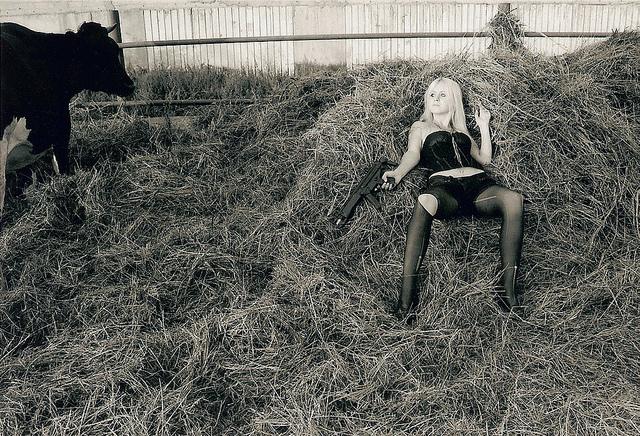Is this woman a model?
Give a very brief answer. Yes. What is the woman holding?
Keep it brief. Gun. What kind of animal is touching the fence?
Concise answer only. Cow. Is the woman laying in a provocative posture?
Answer briefly. Yes. How did the animal die?
Write a very short answer. Shot. 